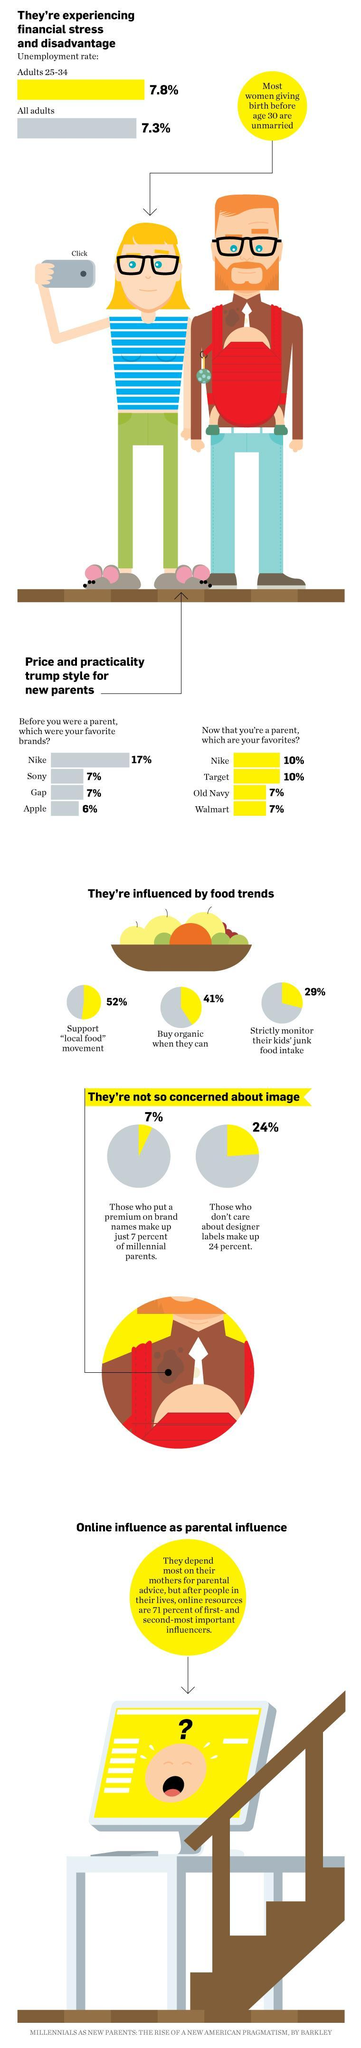What is the favorite brand of people before they were parents?
Answer the question with a short phrase. Nike What percentage of people strictly monitor their kids' junk food intake? 29% What percentage of people support the "local food" movement? 52% What percentage of people buy organic when they can? 41% 